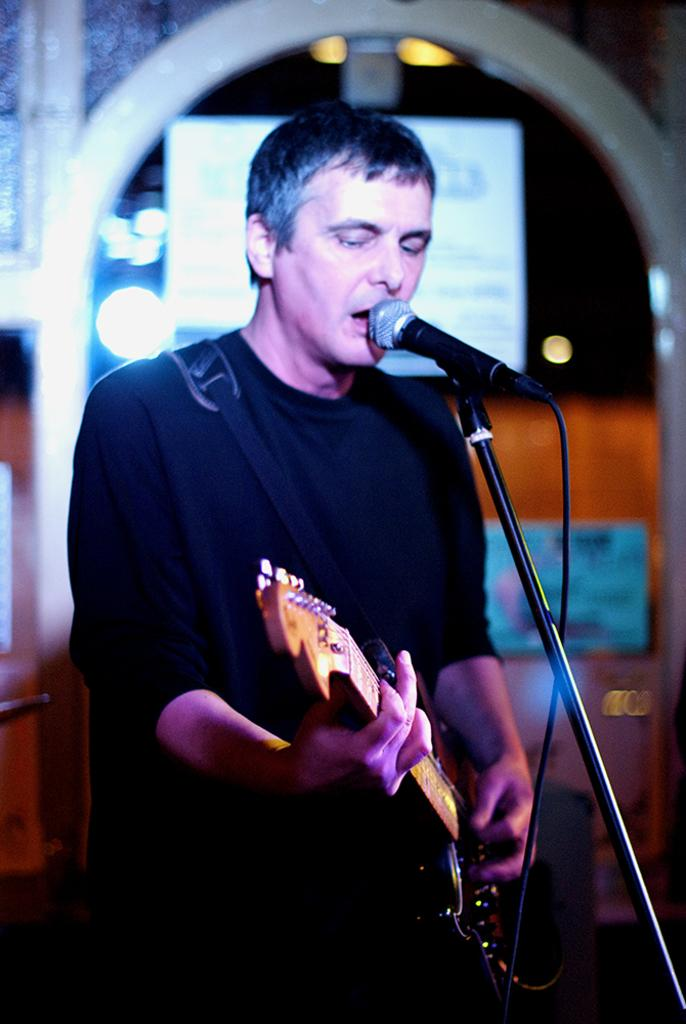Who is the main subject in the image? There is a man in the image. What is the man holding in the image? The man is holding a guitar. What object is in front of the man? The man is in front of a microphone. How many babies are visible in the image? There are no babies present in the image. What type of basin is being used by the man in the image? There is no basin present in the image. 